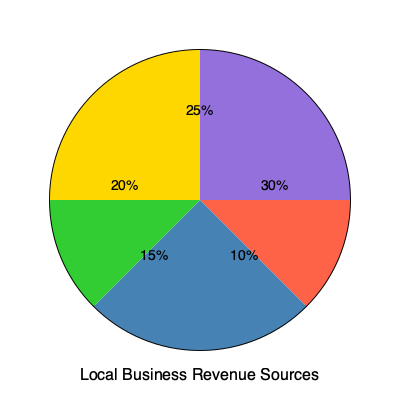Based on the pie chart showing local business revenue sources, what percentage of the total revenue is directly or indirectly related to the defense industry? To answer this question, we need to analyze the pie chart and identify the sections that are related to the defense industry. Let's break it down step-by-step:

1. The pie chart shows five different revenue sources for local businesses.

2. As a small business owner who benefits indirectly from the defense industry, we need to consider both direct and indirect defense-related income.

3. Looking at the chart, we can see the following sections:
   - 30% (red)
   - 25% (purple)
   - 20% (yellow)
   - 15% (blue)
   - 10% (green)

4. The question doesn't specify which sections are defense-related, so we need to make an educated guess based on the context of a small business benefiting indirectly from the defense industry.

5. It's reasonable to assume that the largest section (30%) represents the main local business activity, which is likely not directly defense-related.

6. The second-largest section (25%) could represent indirect benefits from the defense industry, as it's a significant portion but not the majority.

7. The 10% section could represent direct defense-related income, as it's a smaller but still notable portion of the revenue.

8. To calculate the total percentage of revenue related to the defense industry, we add the indirect (25%) and direct (10%) portions:

   $25\% + 10\% = 35\%$

Therefore, the total percentage of revenue directly or indirectly related to the defense industry is 35%.
Answer: 35% 